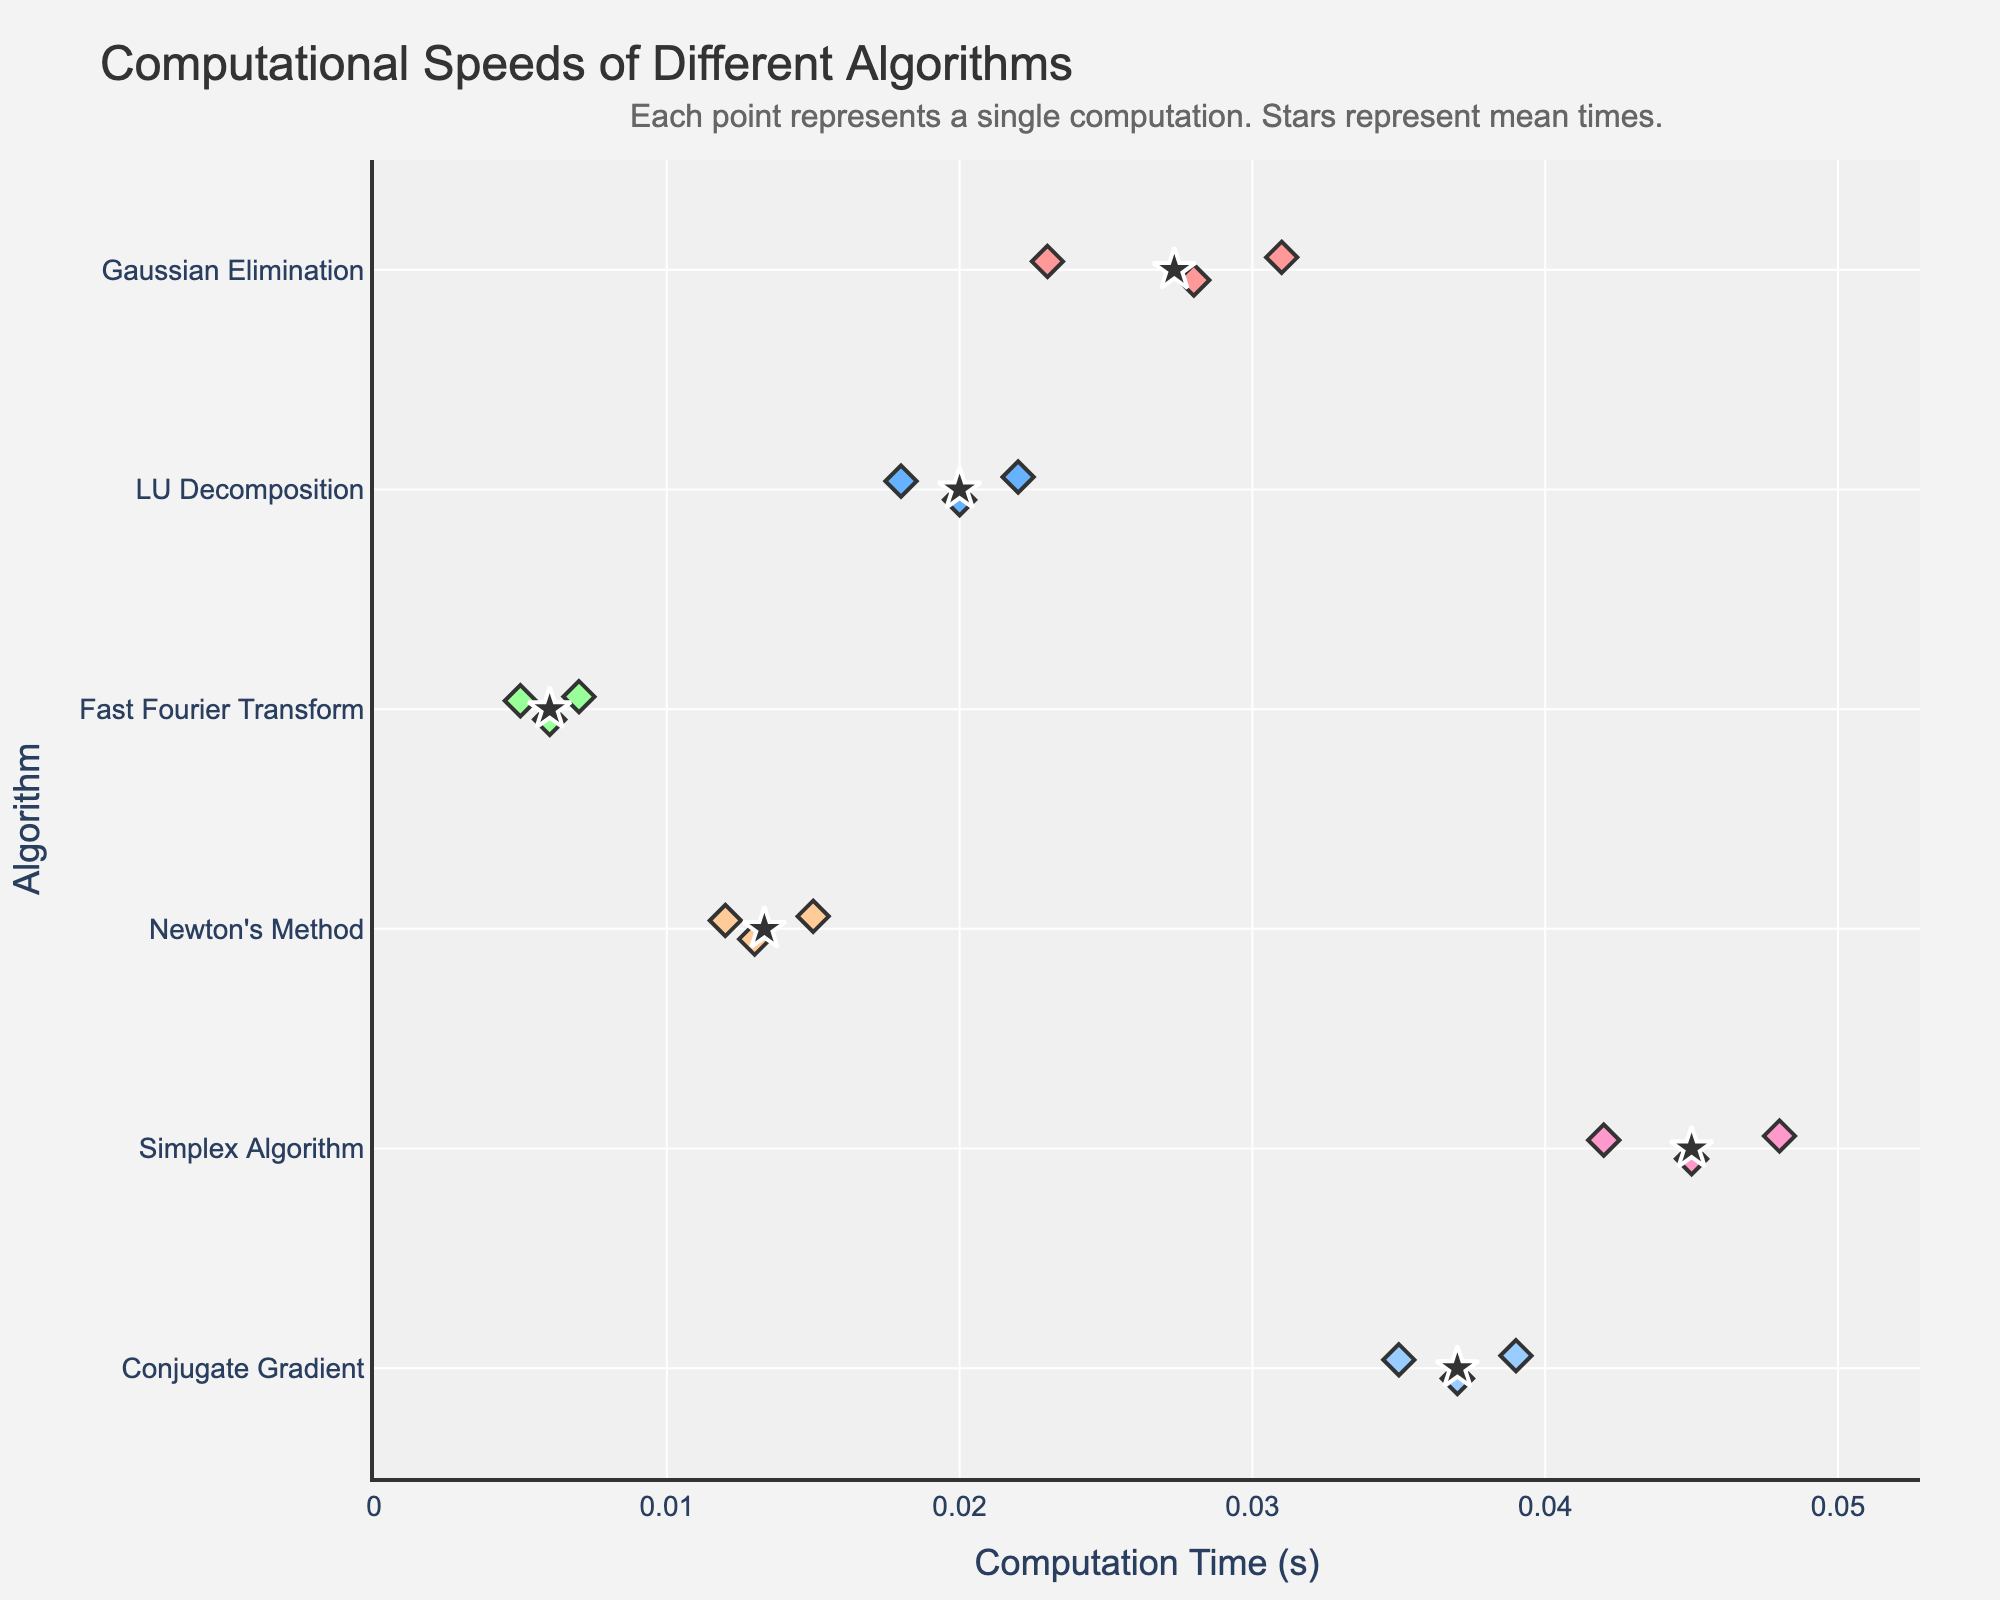What is the title of the figure? The title of the figure is located at the top and it provides an overview of what the plot represents. In this case, it reads "Computational Speeds of Different Algorithms".
Answer: Computational Speeds of Different Algorithms What are the units for the x-axis? The x-axis label indicates the units used for measurement. In this plot, the x-axis is labeled "Computation Time (s)", meaning the units are in seconds.
Answer: seconds Which algorithm has the smallest computation time? The plot shows a strip of points representing computation times for each algorithm. The smallest computation time is the leftmost point on the x-axis. In this case, it is the Fast Fourier Transform, with computation times around 0.005 to 0.007 seconds.
Answer: Fast Fourier Transform How many data points are plotted for Newton's Method? The strip plot shows individual points for each computation time of the algorithms. By counting the points in the row corresponding to Newton's Method, we see there are three data points.
Answer: 3 Which algorithm has the highest mean computation time? The mean computation times are represented by star symbols on the plot. By comparing their positions, the algorithm with the rightmost star has the highest mean computation time. This is the Simplex Algorithm.
Answer: Simplex Algorithm What is the range of computation times for Gaussian Elimination? The strip plot shows individual points for each computation time. For Gaussian Elimination, the points lie between 0.023 and 0.031 seconds.
Answer: 0.023 to 0.031 seconds Which algorithm has greater variability in computation times: LU Decomposition or Conjugate Gradient? Variability can be inferred from the spread of points. For LU Decomposition, points are narrowly spread between 0.018 and 0.022 seconds. For Conjugate Gradient, the points are spread between 0.035 and 0.039 seconds. Conjugate Gradient has greater variability.
Answer: Conjugate Gradient How does the computation time of Fast Fourier Transform compare to that of Simplex Algorithm? Fast Fourier Transform has points clustered around the leftmost part of the x-axis (0.005 to 0.007 seconds). Simplex Algorithm points are on the right part (0.042 to 0.048 seconds). Fast Fourier Transform is much faster.
Answer: Fast Fourier Transform is faster What is the mean computation time for Newton's Method? The mean computation time is indicated by a star symbol. For Newton's Method, the star points to approximately the average value of 0.013 seconds.
Answer: About 0.013 seconds 